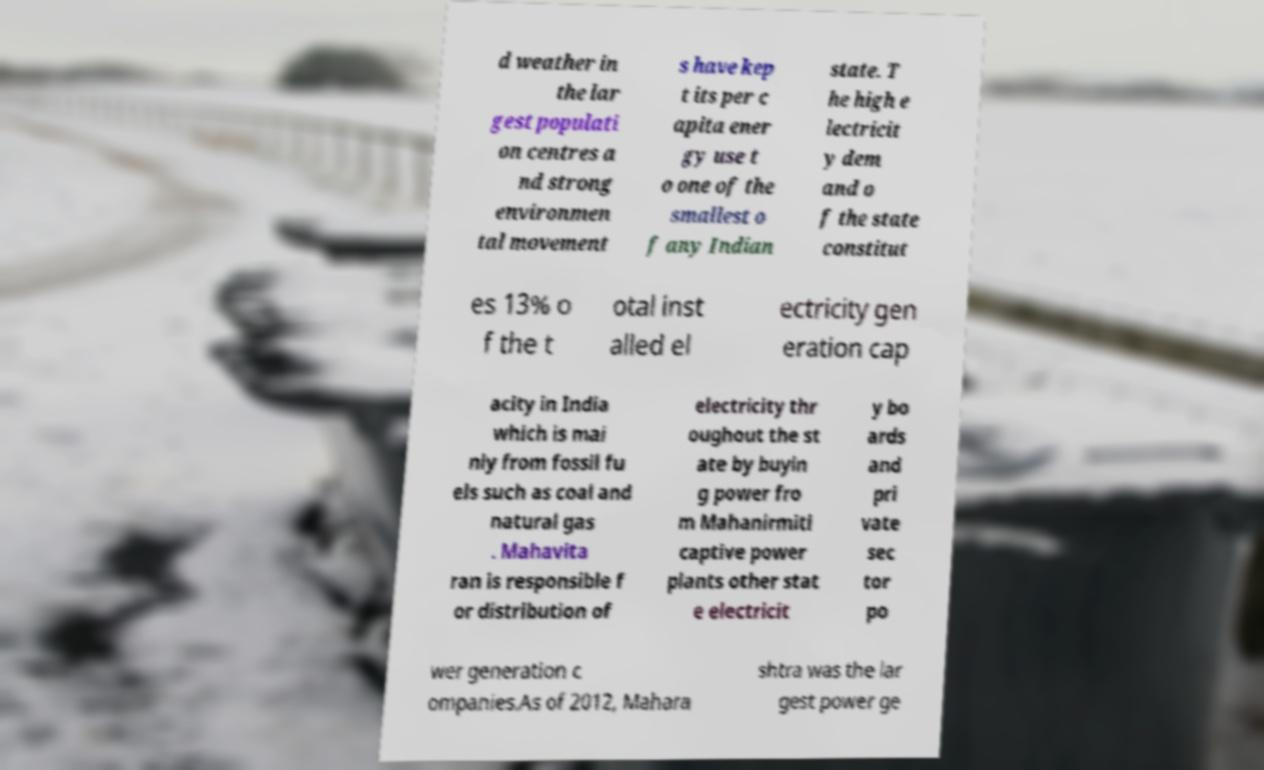What messages or text are displayed in this image? I need them in a readable, typed format. d weather in the lar gest populati on centres a nd strong environmen tal movement s have kep t its per c apita ener gy use t o one of the smallest o f any Indian state. T he high e lectricit y dem and o f the state constitut es 13% o f the t otal inst alled el ectricity gen eration cap acity in India which is mai nly from fossil fu els such as coal and natural gas . Mahavita ran is responsible f or distribution of electricity thr oughout the st ate by buyin g power fro m Mahanirmiti captive power plants other stat e electricit y bo ards and pri vate sec tor po wer generation c ompanies.As of 2012, Mahara shtra was the lar gest power ge 